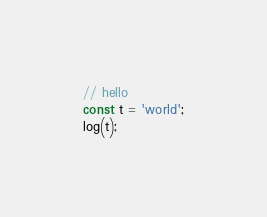Convert code to text. <code><loc_0><loc_0><loc_500><loc_500><_JavaScript_>// hello
const t = 'world';
log(t);

</code> 